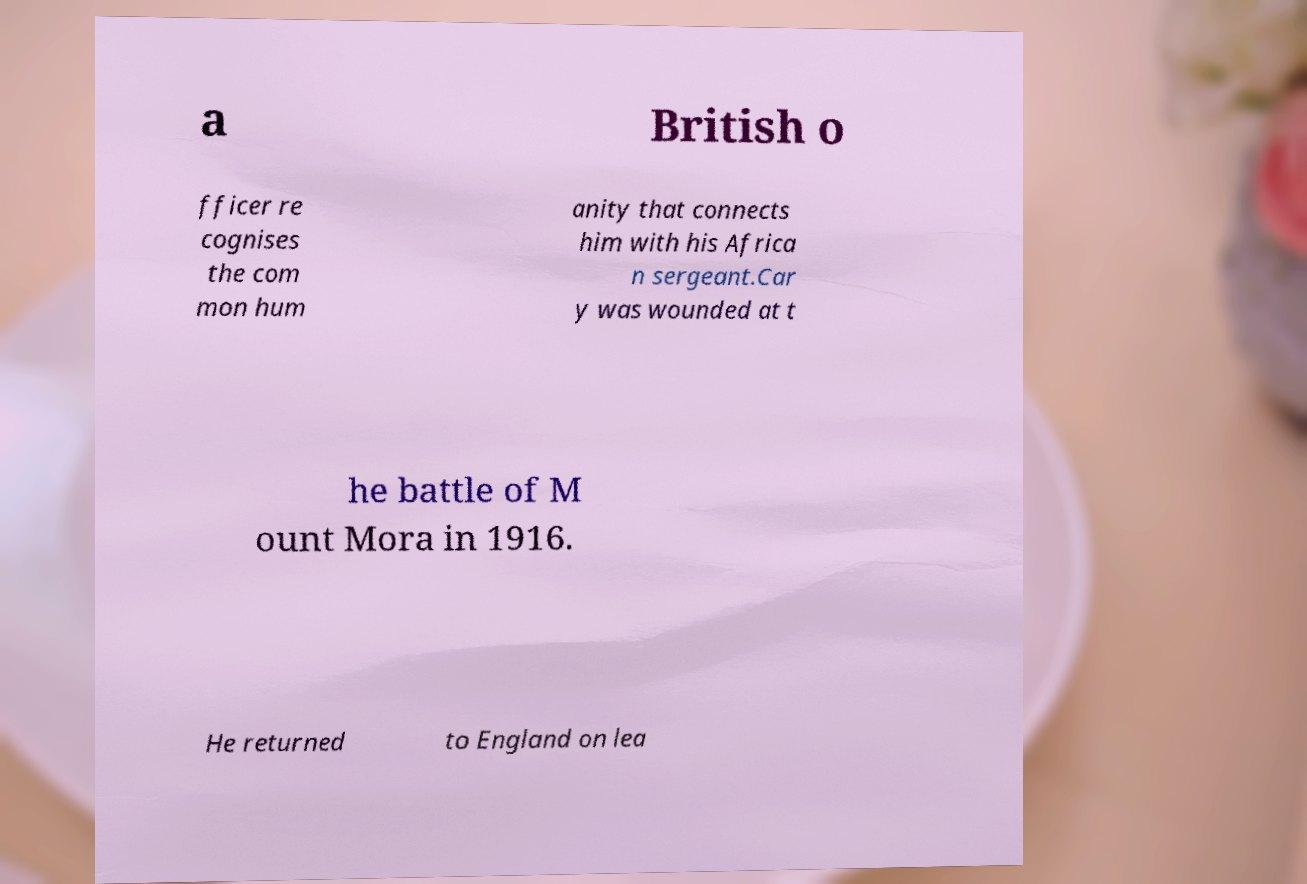Can you read and provide the text displayed in the image?This photo seems to have some interesting text. Can you extract and type it out for me? a British o fficer re cognises the com mon hum anity that connects him with his Africa n sergeant.Car y was wounded at t he battle of M ount Mora in 1916. He returned to England on lea 